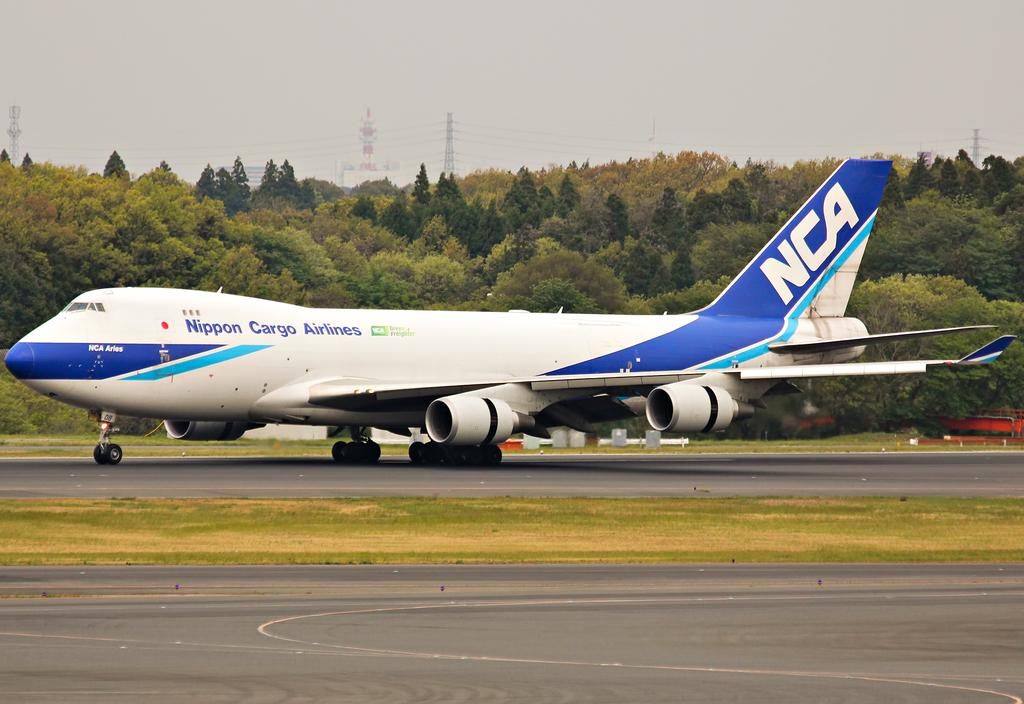What is the main subject of the image? The main subject of the image is an aircraft. Where is the aircraft located in the image? The aircraft is on the land in the image. What can be seen in the background of the image? There are trees and towers in the background of the image. What type of elbow is visible on the aircraft in the image? There is no elbow visible on the aircraft in the image, as elbows are not a part of an aircraft. What type of wall can be seen surrounding the aircraft in the image? There is no wall surrounding the aircraft in the image. --- Facts: 1. There is a person holding a book in the image. 2. The person is sitting on a chair. 3. There is a table in the image. 4. The table has a lamp on it. 5. There is a window in the room. Absurd Topics: elephant, ocean, bicycle Conversation: What is the person in the image holding? The person in the image is holding a book. What is the person sitting on in the image? The person is sitting on a chair. What other piece of furniture is present in the image? There is a table in the image. What is on the table in the image? The table has a lamp on it. What is visible through the window in the image? There is a window in the room, but the facts provided do not specify what is visible through it. Reasoning: Let's think step by step in order to produce the conversation. We start by identifying the main subject of the image, which is the person holding a book. Then, we describe the person's position and the presence of a chair. Next, we mention the table and the lamp on it. Finally, we acknowledge the presence of a window in the room, but we do not speculate on what is visible through it, as the provided facts do not give us that information. Absurd Question/Answer: How many elephants can be seen swimming in the ocean in the image? There are no elephants or ocean present in the image. What type of bicycle is leaning against the wall in the image? There is no bicycle or wall present in the image. 